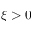Convert formula to latex. <formula><loc_0><loc_0><loc_500><loc_500>\xi > 0</formula> 